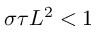<formula> <loc_0><loc_0><loc_500><loc_500>\sigma \tau L ^ { 2 } < 1</formula> 